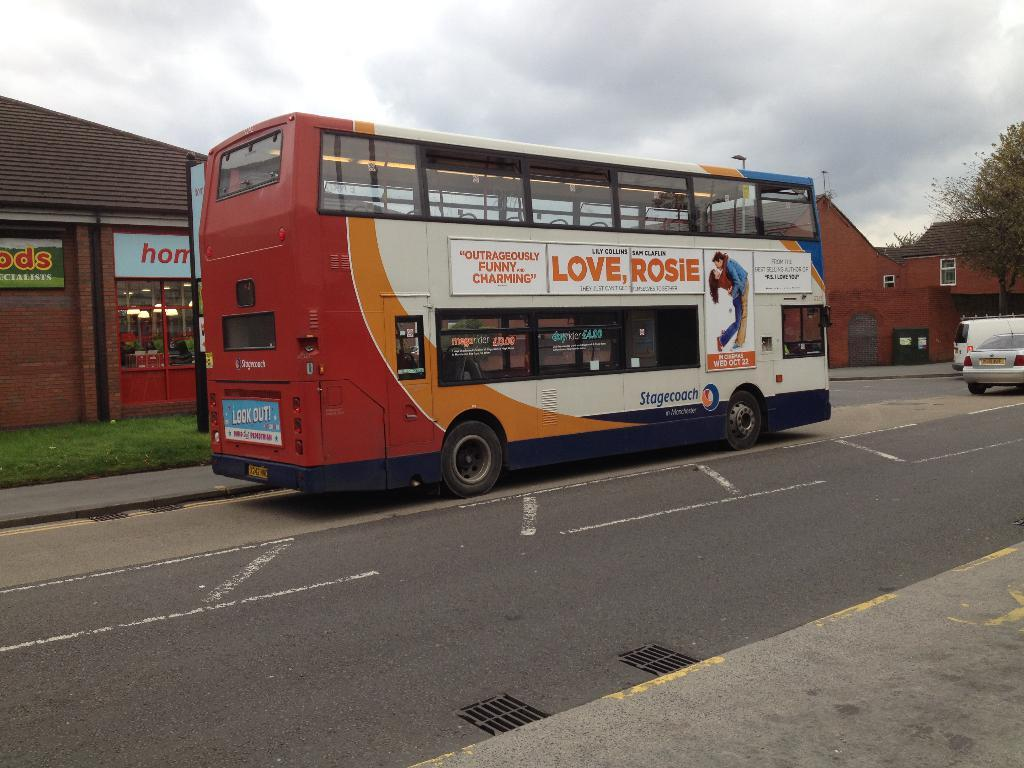<image>
Provide a brief description of the given image. the words love rosie that is on a bus 